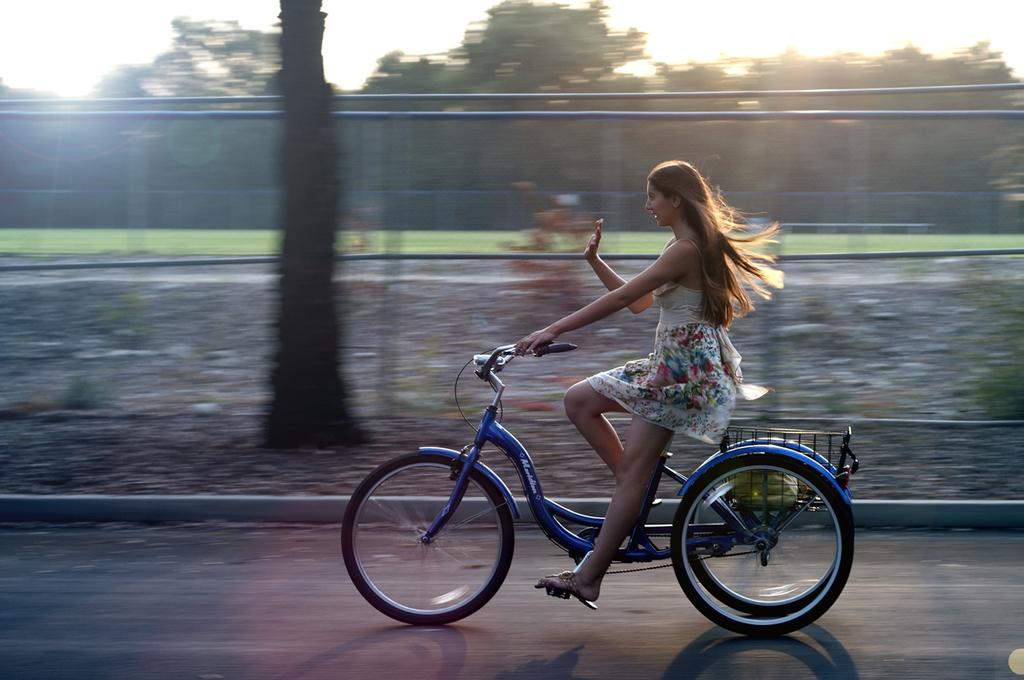What can be seen in the background of the image? There is a sky and trees visible in the background of the image. What object is present in the image that is typically used for catching or holding things? There is a net in the image. What activity is the woman in the image engaged in? The woman is riding a bicycle on the road in the image. What type of pin is holding the stem of the appliance in the image? There is no pin, stem, or appliance present in the image. 